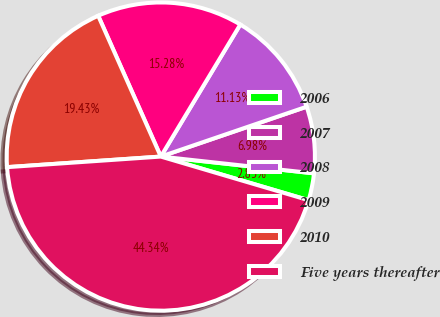Convert chart to OTSL. <chart><loc_0><loc_0><loc_500><loc_500><pie_chart><fcel>2006<fcel>2007<fcel>2008<fcel>2009<fcel>2010<fcel>Five years thereafter<nl><fcel>2.83%<fcel>6.98%<fcel>11.13%<fcel>15.28%<fcel>19.43%<fcel>44.33%<nl></chart> 